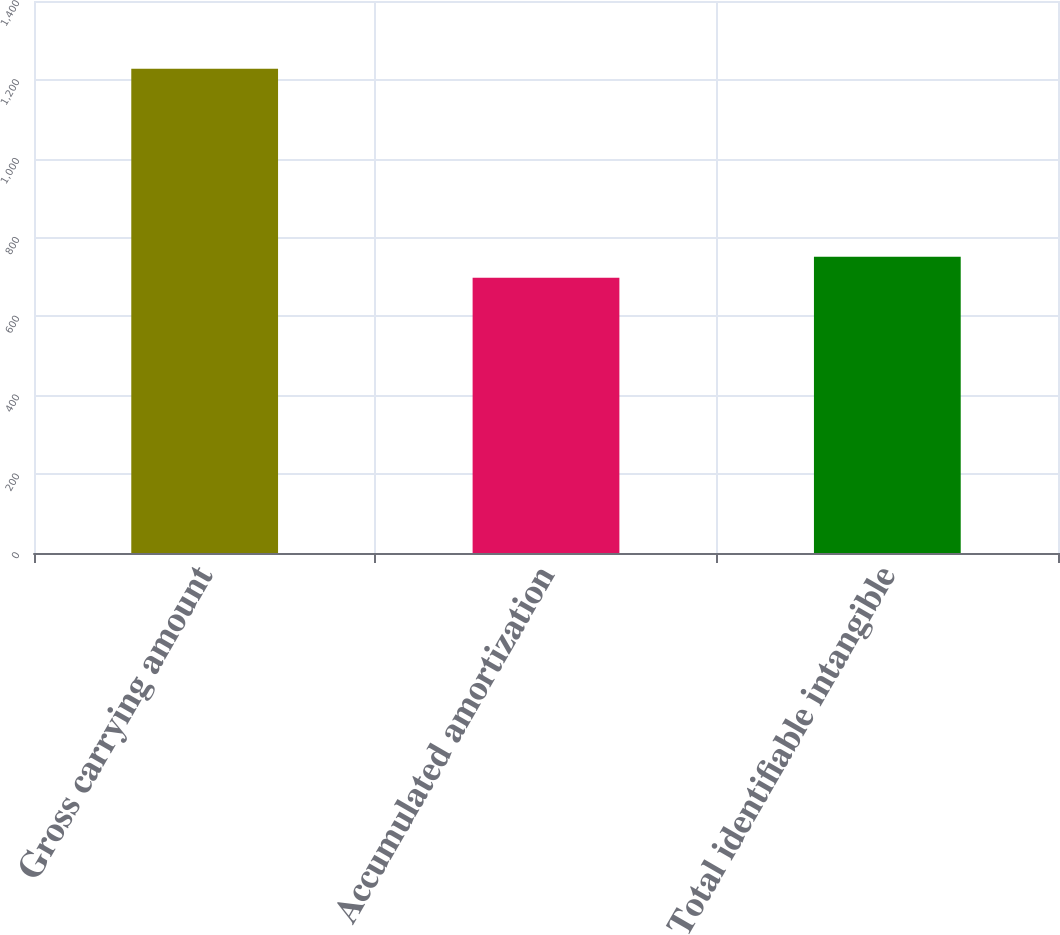<chart> <loc_0><loc_0><loc_500><loc_500><bar_chart><fcel>Gross carrying amount<fcel>Accumulated amortization<fcel>Total identifiable intangible<nl><fcel>1228.4<fcel>698.1<fcel>751.13<nl></chart> 